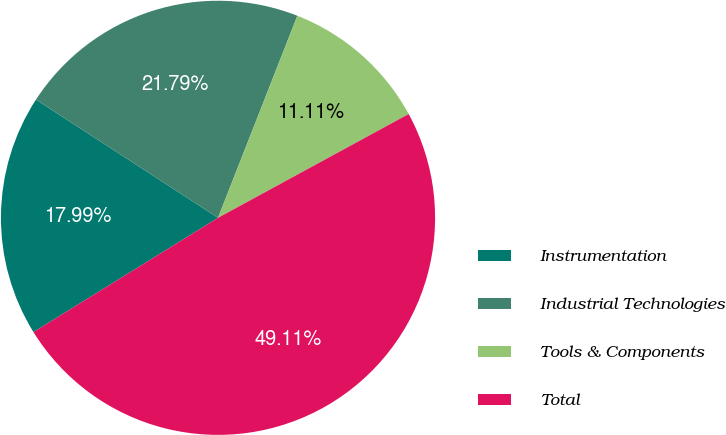<chart> <loc_0><loc_0><loc_500><loc_500><pie_chart><fcel>Instrumentation<fcel>Industrial Technologies<fcel>Tools & Components<fcel>Total<nl><fcel>17.99%<fcel>21.79%<fcel>11.11%<fcel>49.11%<nl></chart> 